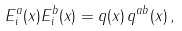Convert formula to latex. <formula><loc_0><loc_0><loc_500><loc_500>E ^ { a } _ { i } ( x ) E ^ { b } _ { i } ( x ) = q ( x ) \, q ^ { a b } ( x ) \, ,</formula> 